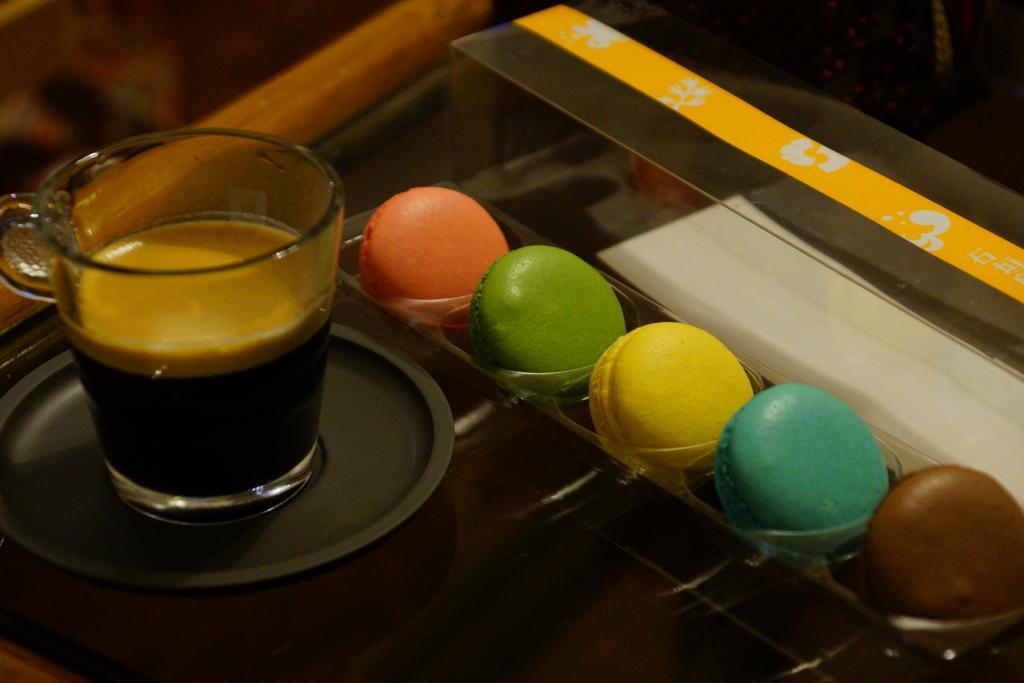Please provide a concise description of this image. In this image there is a glass with the coffee in it. Beside the glass there are bundt cakes which are kept in the box. The cup is on the plate. 